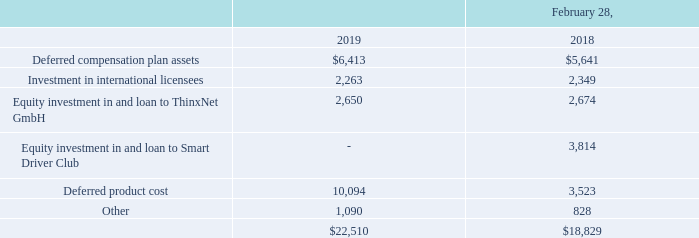NOTE 9 – OTHER ASSETS
Other assets consist of the following (in thousands):
We have a non-qualified deferred compensation plan in which certain members of management and all nonemployee
directors are eligible to participate. Participants may defer a portion of their compensation until retirement
or another date specified by them in accordance with the plan. We are funding the plan obligations through cash
deposits to a Rabbi Trust that are invested in various equity, bond and money market mutual funds in generally the
same proportion as investment elections made by the participants. The deferred compensation plan liability is included
in Other Non-Current Liabilities in the accompanying consolidated balance sheets.
Our investment in international licensees at February 28, 2019 consists principally of a 12.5% equity interest in
a Mexican licensee of $1.7 million, which became a wholly-owned subsidiary as of March 19, 2019 (see Note 2), as
well as other smaller interests in Benelux and French licensees. Generally, the investments in international licensees
are accounted for using the cost method of accounting and carried at cost as we do not exercise significant influence
over these investees. We have received dividends from our investment in the Mexican licensee in the amount of $0.3
million, $0.3 million and $0.2 million for fiscal years ended February 28, 2019, 2018 and 2017, respectively.
In September 2015, we invested £1,400,000 or approximately $2.2 million for a 49% minority ownership
interest in Smart Driver Club Limited (“Smart Driver Club”), a technology and insurance startup company located in
the United Kingdom. This investment has been accounted for under the equity method since we have significant
influence over the investee. As of February 28, 2019, we had made loans aggregating £5,700,000 or approximately
$7.6 million to Smart Driver Club bearing interest at an annual interest rate of 8%, with all principal and all unpaid
interest due in 2021. Our equity in the net loss of Smart Driver Club amounted to $1.8 million, $1.4 million and $1.3
million in fiscal years ended February 28, 2019, 2018 and 2017, respectively. As of February 28, 2019, we determined
that this equity method investment was subject to other than temporary impairment. This decision was dictated by the
continuing operating losses and deteriorating liquidity position of Smart Driver Club. Accordingly, we recorded an
impairment charge of $5.0 million in the impairment loss and equity in net loss within our consolidated statement of
comprehensive income (loss). Smart Driver Club drew an additional £400,000 of debt on March 26, 2019 under a
fourth amendment to the original agreement dated March 14, 2019
Effective August 24, 2017, we acquired an ownership interest valued at $1.4 million in ThinxNet GmbH, a
company headquartered in Munich, Germany (“ThinxNet”). ThinxNet is an early stage company focused on
commercializing cloud-based mobile device and applications in the automotive sector throughout Europe. This
represents a cost basis investment as we cannot exercise significant influence over the investee. Contemporaneously,
we executed an unsecured convertible note receivable for $1.27 million with an interest rate of 6%, which has a fixed
term of 12 months, after which the loan can be converted into equity in ThinxNet or a loan due on demand at our
option. The equity investment and note receivable were consideration we received in exchange for our outstanding
accounts receivable from ThinxNet. No gain or loss was recorded on this exchange. The assets received in this
exchange are included in Other Assets in the consolidated balance sheet as of February 28, 2019 and 2018.
In August 2018, ThinxNet commenced a subsequent financing transaction to raise additional funds for working capital purposes. In connection with this transaction, we converted approximately $300,000 of outstanding accounts receivable due from ThinxNet into additional ownership interest in an in-kind exchange of assets. Based on the fair value of ThinxNet at the time of conversion, we revalued the initial ownership interest and recorded an impairment charge of $326,000, which is netted within Investment Income in our consolidated statement of comprehensive income (loss). Effective March 2019, we notified ThinxNet that we expect the outstanding loan to be repaid in June 2019.
What did ThinxNet do in August 2018? Commenced a subsequent financing transaction to raise additional funds for working capital purposes. How much was deferred compensation in 2019?
Answer scale should be: thousand. 6,413. How much was deferred product cost in 2019?
Answer scale should be: thousand. 10,094. What was the change in investment in international licenses from 2018 to 2019?
Answer scale should be: thousand. (2,349-2,263)
Answer: 86. What was the percentage change in product costs from 2018 to 2019?
Answer scale should be: percent. (10,094-3,523)/3,523
Answer: 186.52. How much do the top 3 assets add up to in 2018?
Answer scale should be: thousand. (5,641+3,814+3,523)
Answer: 12978. 